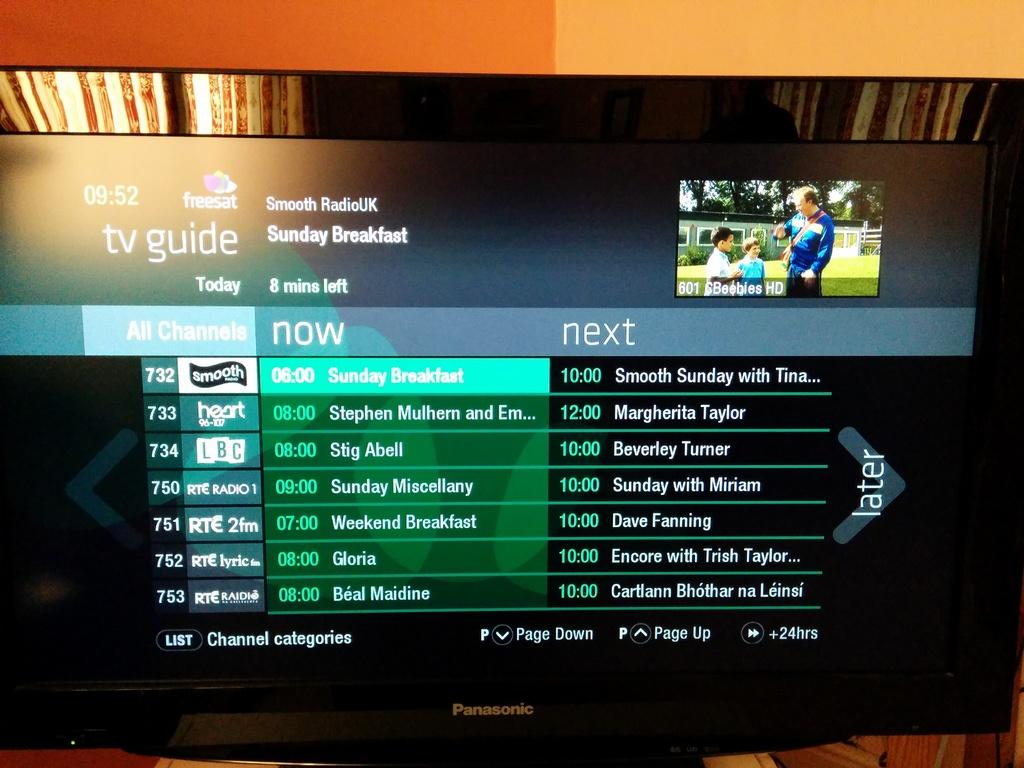<image>
Give a short and clear explanation of the subsequent image. The tv guide is displaying radio programs that are currently available. 